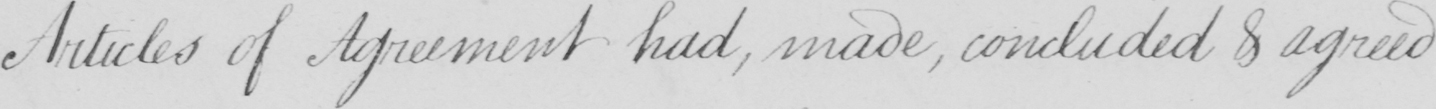What text is written in this handwritten line? Articles of Agreement had , made , concluded & agreed 